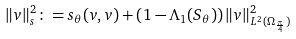<formula> <loc_0><loc_0><loc_500><loc_500>\| v \| ^ { 2 } _ { s } \colon = s _ { \theta } ( v , v ) + \left ( 1 - \Lambda _ { 1 } ( S _ { \theta } ) \right ) \| v \| ^ { 2 } _ { L ^ { 2 } ( \Omega _ { \frac { \pi } { 4 } } ) }</formula> 